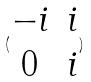<formula> <loc_0><loc_0><loc_500><loc_500>( \begin{matrix} - i & i \\ 0 & i \end{matrix} )</formula> 